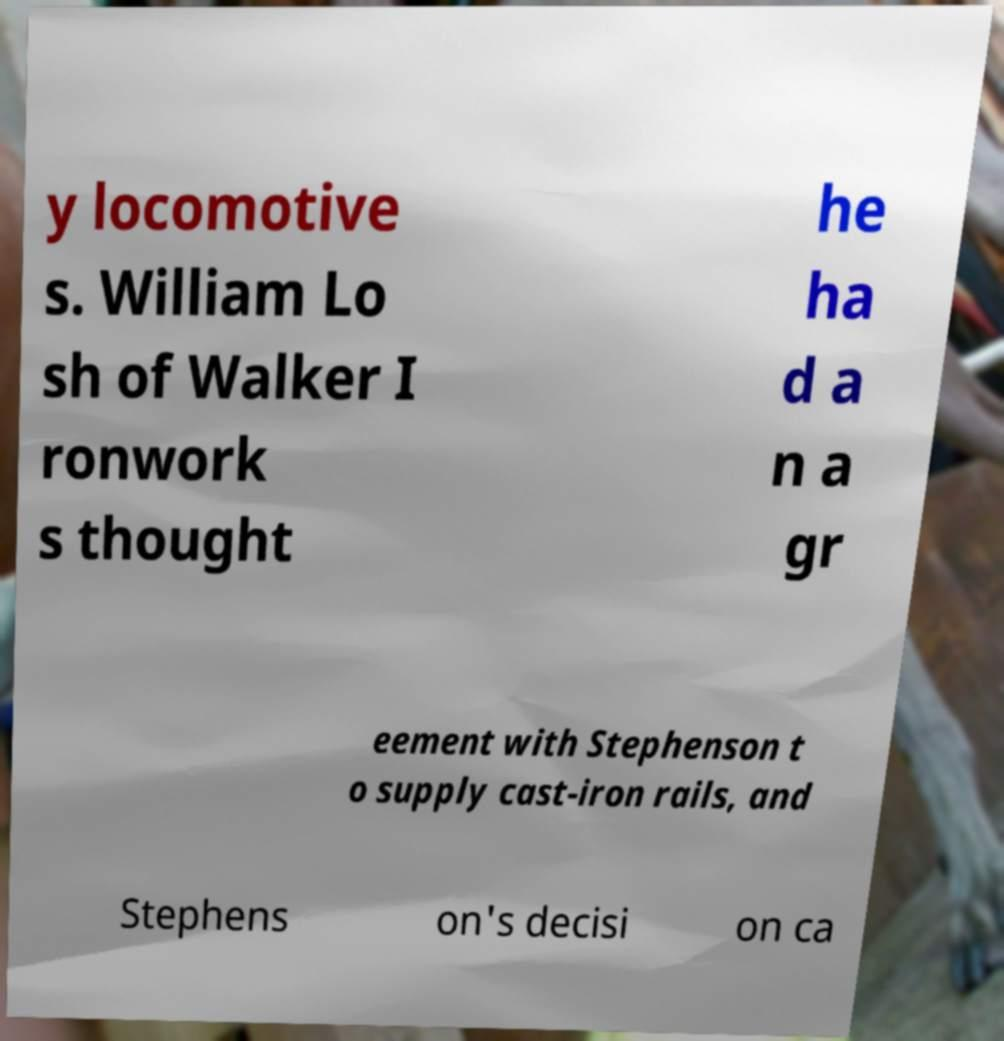Please identify and transcribe the text found in this image. y locomotive s. William Lo sh of Walker I ronwork s thought he ha d a n a gr eement with Stephenson t o supply cast-iron rails, and Stephens on's decisi on ca 